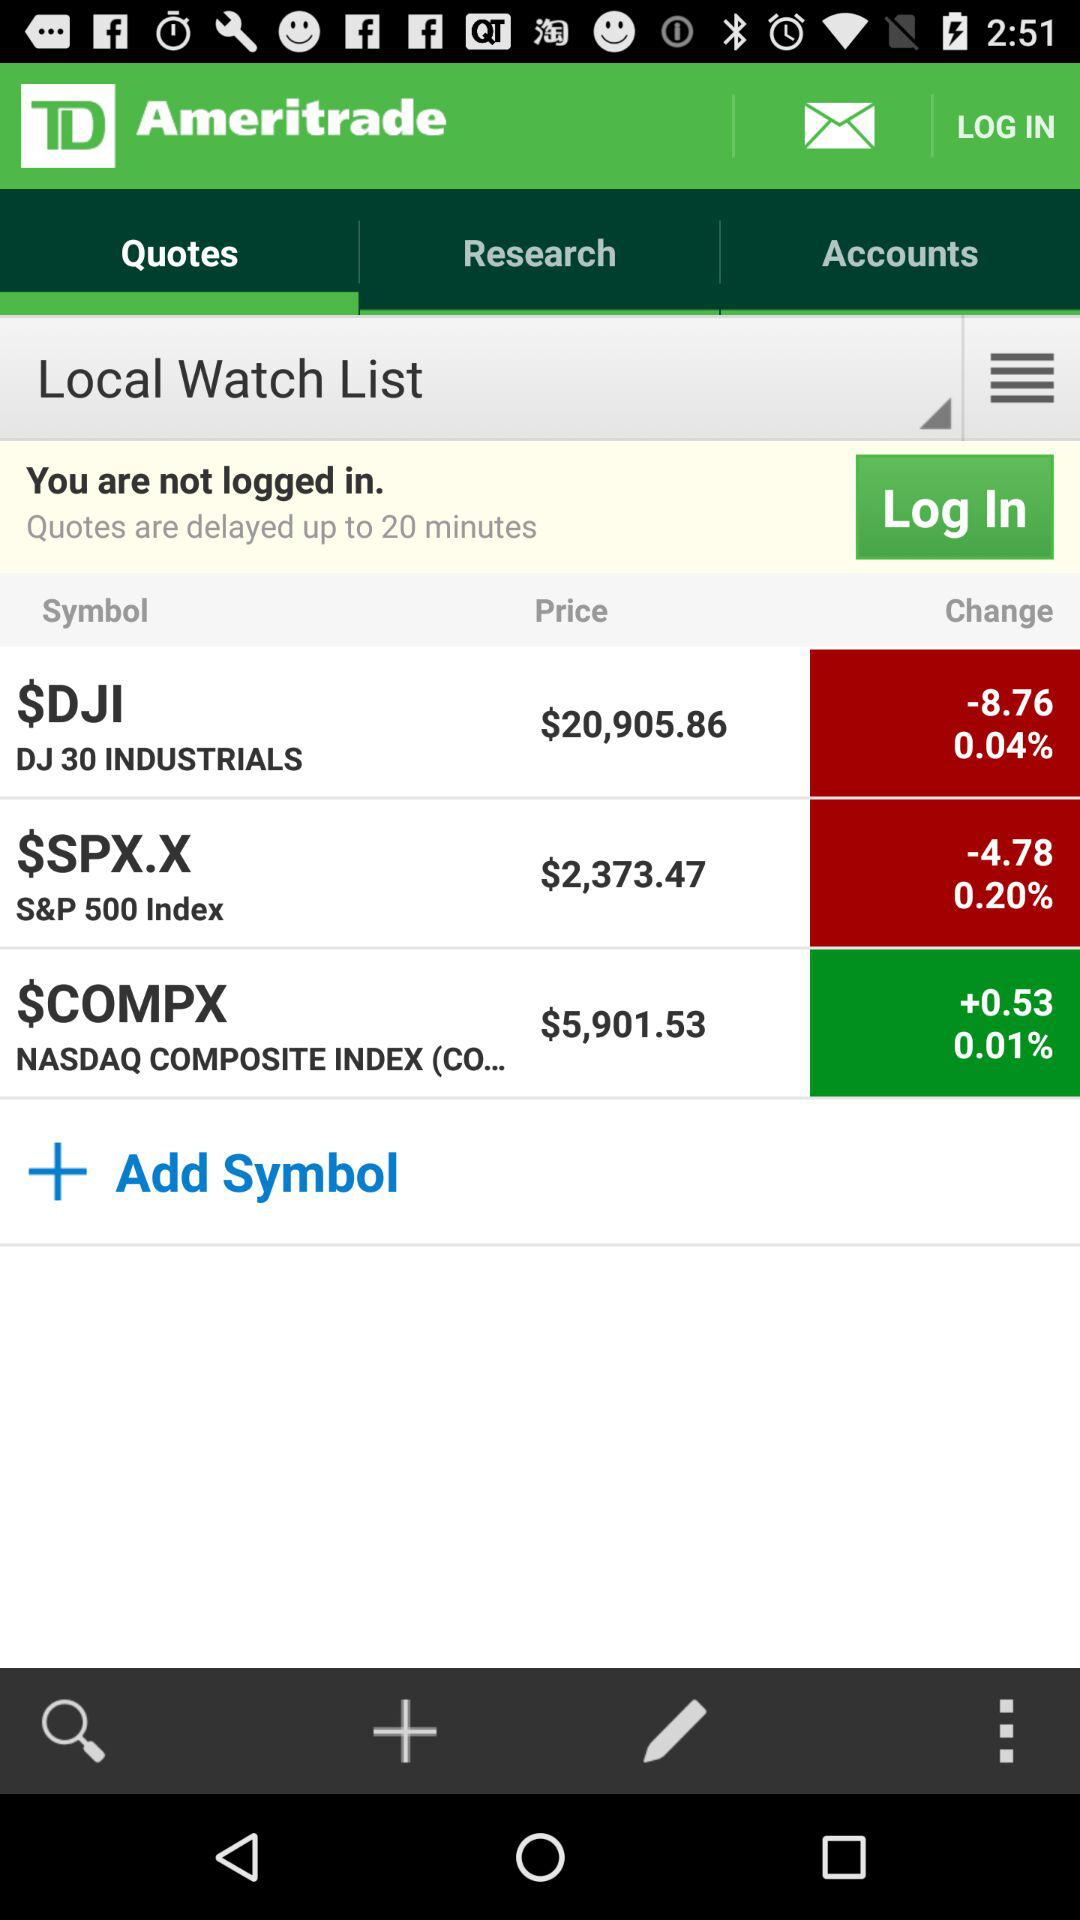Which tab is selected? The selected tab is "Quotes". 